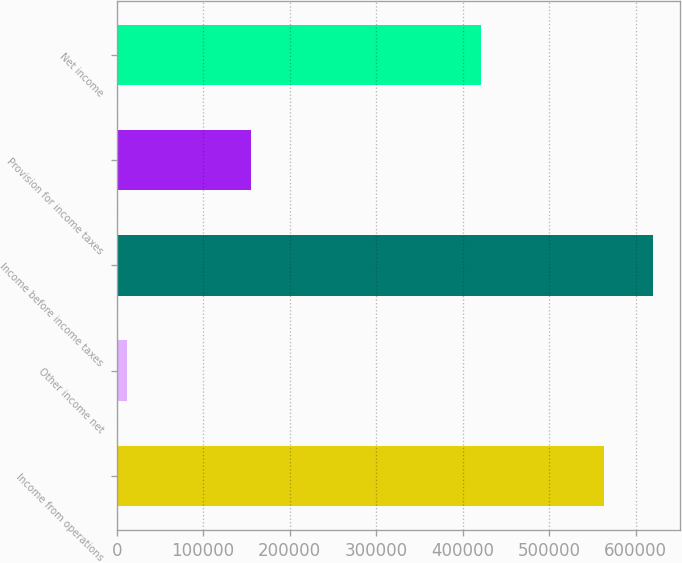<chart> <loc_0><loc_0><loc_500><loc_500><bar_chart><fcel>Income from operations<fcel>Other income net<fcel>Income before income taxes<fcel>Provision for income taxes<fcel>Net income<nl><fcel>563956<fcel>11561<fcel>620352<fcel>154756<fcel>420761<nl></chart> 